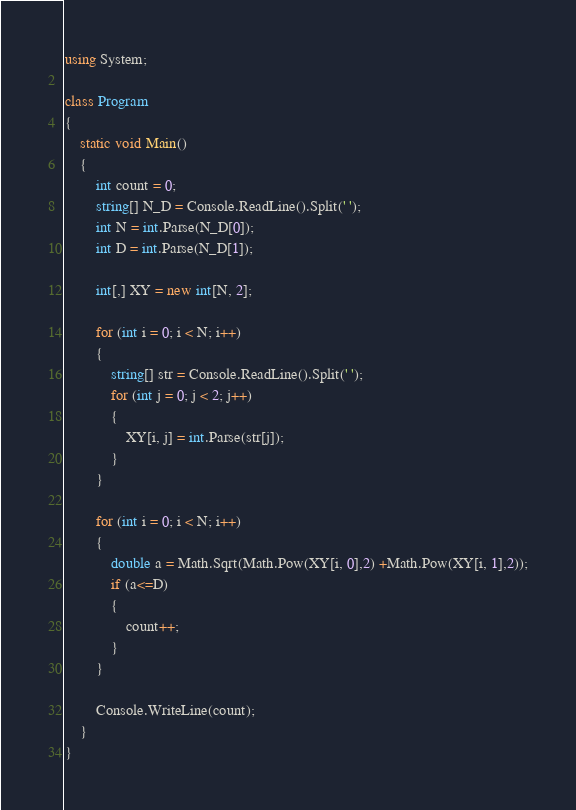Convert code to text. <code><loc_0><loc_0><loc_500><loc_500><_C#_>using System;

class Program
{
    static void Main()
    {
        int count = 0;
        string[] N_D = Console.ReadLine().Split(' ');
        int N = int.Parse(N_D[0]);
        int D = int.Parse(N_D[1]);

        int[,] XY = new int[N, 2];

        for (int i = 0; i < N; i++)
        {
            string[] str = Console.ReadLine().Split(' ');
            for (int j = 0; j < 2; j++)
            {
                XY[i, j] = int.Parse(str[j]);
            }
        }

        for (int i = 0; i < N; i++)
        {
            double a = Math.Sqrt(Math.Pow(XY[i, 0],2) +Math.Pow(XY[i, 1],2));
            if (a<=D)
            {
                count++;
            }
        }

        Console.WriteLine(count);
    }
}</code> 